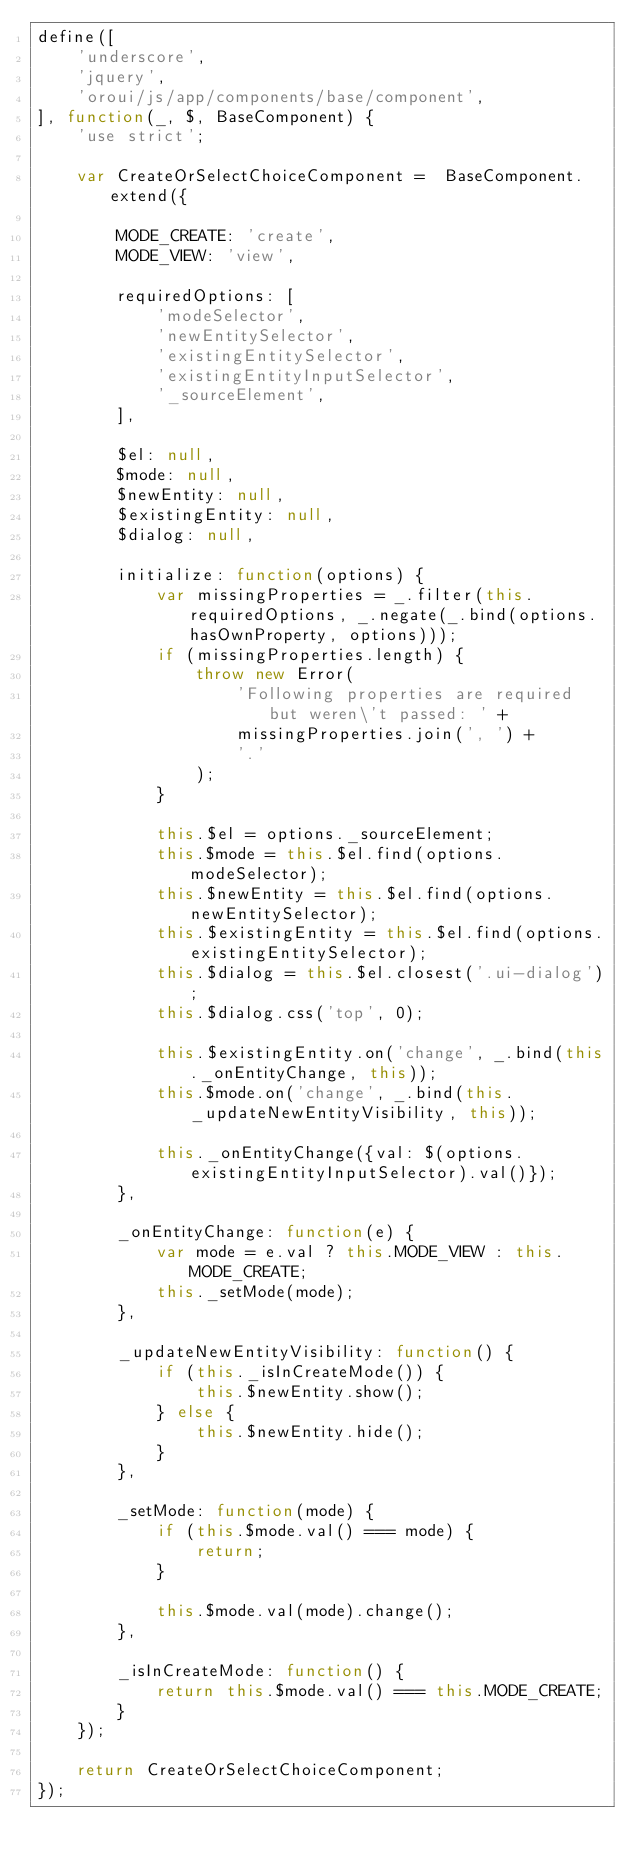Convert code to text. <code><loc_0><loc_0><loc_500><loc_500><_JavaScript_>define([
    'underscore',
    'jquery',
    'oroui/js/app/components/base/component',
], function(_, $, BaseComponent) {
    'use strict';

    var CreateOrSelectChoiceComponent =  BaseComponent.extend({

        MODE_CREATE: 'create',
        MODE_VIEW: 'view',

        requiredOptions: [
            'modeSelector',
            'newEntitySelector',
            'existingEntitySelector',
            'existingEntityInputSelector',
            '_sourceElement',
        ],

        $el: null,
        $mode: null,
        $newEntity: null,
        $existingEntity: null,
        $dialog: null,

        initialize: function(options) {
            var missingProperties = _.filter(this.requiredOptions, _.negate(_.bind(options.hasOwnProperty, options)));
            if (missingProperties.length) {
                throw new Error(
                    'Following properties are required but weren\'t passed: ' +
                    missingProperties.join(', ') +
                    '.'
                );
            }

            this.$el = options._sourceElement;
            this.$mode = this.$el.find(options.modeSelector);
            this.$newEntity = this.$el.find(options.newEntitySelector);
            this.$existingEntity = this.$el.find(options.existingEntitySelector);
            this.$dialog = this.$el.closest('.ui-dialog');
            this.$dialog.css('top', 0);

            this.$existingEntity.on('change', _.bind(this._onEntityChange, this));
            this.$mode.on('change', _.bind(this._updateNewEntityVisibility, this));

            this._onEntityChange({val: $(options.existingEntityInputSelector).val()});
        },

        _onEntityChange: function(e) {
            var mode = e.val ? this.MODE_VIEW : this.MODE_CREATE;
            this._setMode(mode);
        },

        _updateNewEntityVisibility: function() {
            if (this._isInCreateMode()) {
                this.$newEntity.show();
            } else {
                this.$newEntity.hide();
            }
        },

        _setMode: function(mode) {
            if (this.$mode.val() === mode) {
                return;
            }

            this.$mode.val(mode).change();
        },

        _isInCreateMode: function() {
            return this.$mode.val() === this.MODE_CREATE;
        }
    });

    return CreateOrSelectChoiceComponent;
});
</code> 